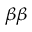Convert formula to latex. <formula><loc_0><loc_0><loc_500><loc_500>_ { \beta \beta }</formula> 